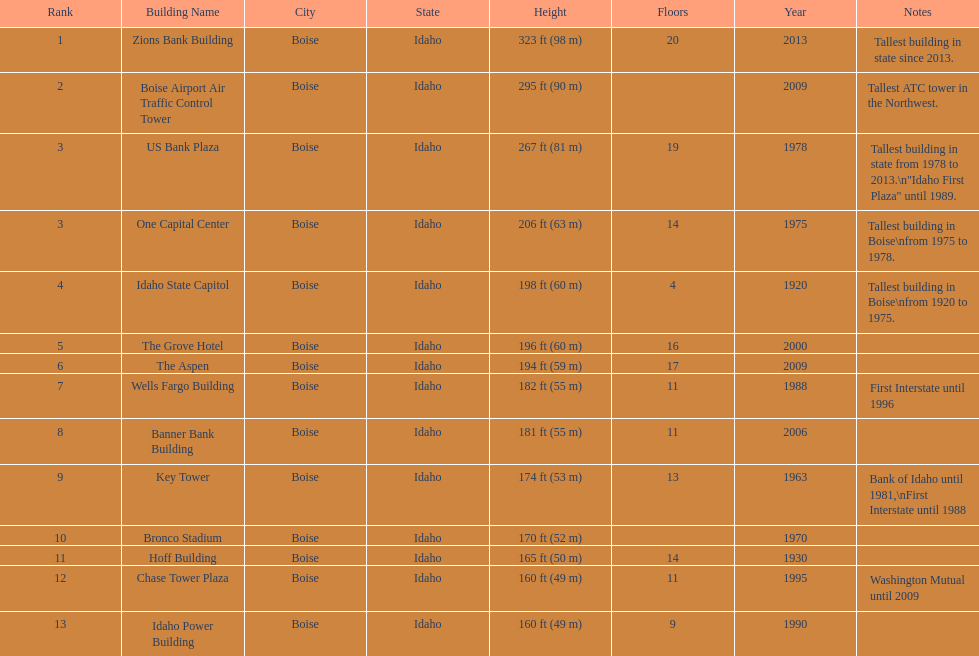How tall (in meters) is the tallest building? 98 m. 